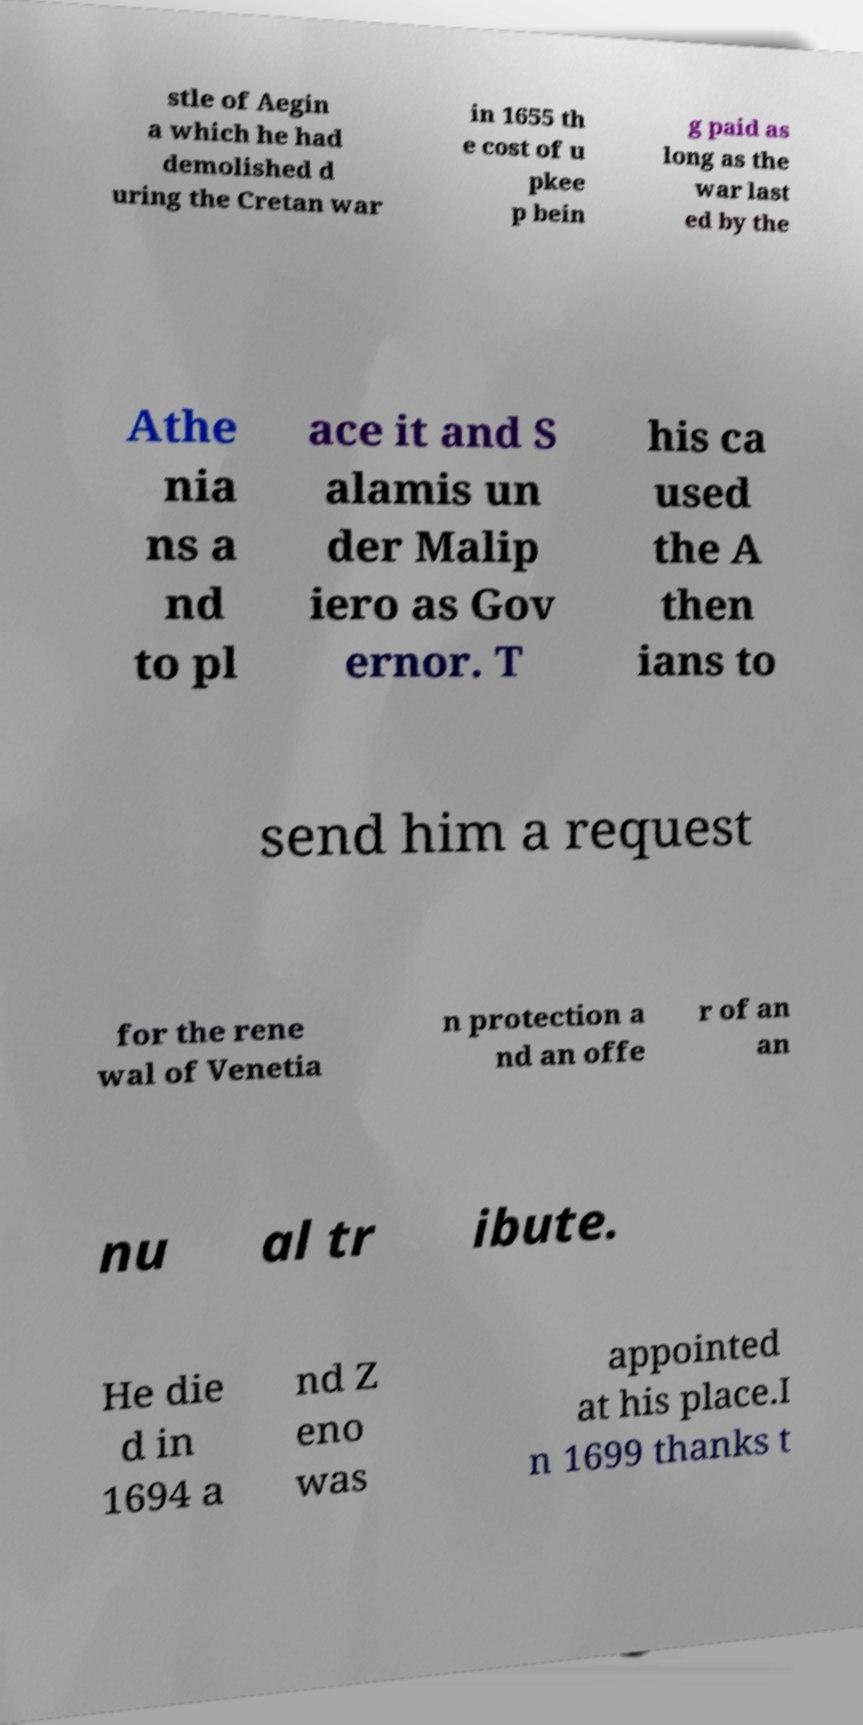Please read and relay the text visible in this image. What does it say? stle of Aegin a which he had demolished d uring the Cretan war in 1655 th e cost of u pkee p bein g paid as long as the war last ed by the Athe nia ns a nd to pl ace it and S alamis un der Malip iero as Gov ernor. T his ca used the A then ians to send him a request for the rene wal of Venetia n protection a nd an offe r of an an nu al tr ibute. He die d in 1694 a nd Z eno was appointed at his place.I n 1699 thanks t 